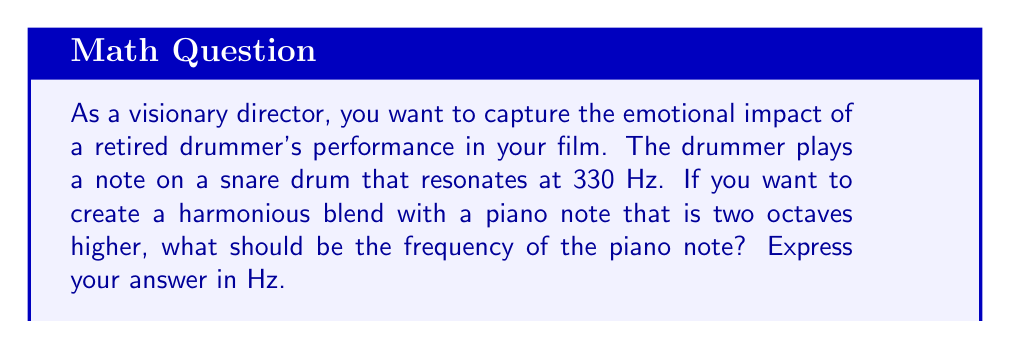Could you help me with this problem? To solve this problem, we need to understand the relationship between octaves and frequency:

1. Each octave represents a doubling of frequency.
2. Two octaves higher means we need to double the frequency twice.

Let's approach this step-by-step:

1. Start with the given frequency of the snare drum:
   $f_{snare} = 330 \text{ Hz}$

2. For one octave higher, we double the frequency:
   $f_{1st\text{ octave}} = 330 \times 2 = 660 \text{ Hz}$

3. For two octaves higher, we double the frequency again:
   $f_{2nd\text{ octave}} = 660 \times 2 = 1320 \text{ Hz}$

Therefore, the frequency of the piano note that is two octaves higher than the snare drum note is 1320 Hz.

We can express this mathematically as:

$$f_{piano} = f_{snare} \times 2^2 = 330 \times 2^2 = 330 \times 4 = 1320 \text{ Hz}$$

Where:
$f_{piano}$ is the frequency of the piano note
$f_{snare}$ is the frequency of the snare drum note
$2^2$ represents doubling the frequency twice (two octaves)
Answer: 1320 Hz 